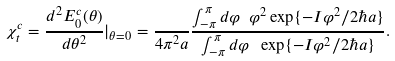Convert formula to latex. <formula><loc_0><loc_0><loc_500><loc_500>\chi ^ { c } _ { t } = \frac { d ^ { 2 } E _ { 0 } ^ { c } ( \theta ) } { d \theta ^ { 2 } } | _ { \theta = 0 } = \frac { } { 4 \pi ^ { 2 } a } \frac { \int _ { - \pi } ^ { \pi } d \varphi \ \varphi ^ { 2 } \exp \{ - I \varphi ^ { 2 } / 2 \hbar { a } \} } { \int _ { - \pi } ^ { \pi } d \varphi \ \exp \{ - I \varphi ^ { 2 } / 2 \hbar { a } \} } .</formula> 